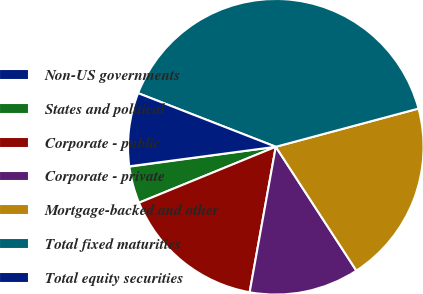Convert chart to OTSL. <chart><loc_0><loc_0><loc_500><loc_500><pie_chart><fcel>Non-US governments<fcel>States and political<fcel>Corporate - public<fcel>Corporate - private<fcel>Mortgage-backed and other<fcel>Total fixed maturities<fcel>Total equity securities<nl><fcel>0.04%<fcel>4.03%<fcel>15.99%<fcel>12.01%<fcel>19.98%<fcel>39.92%<fcel>8.02%<nl></chart> 